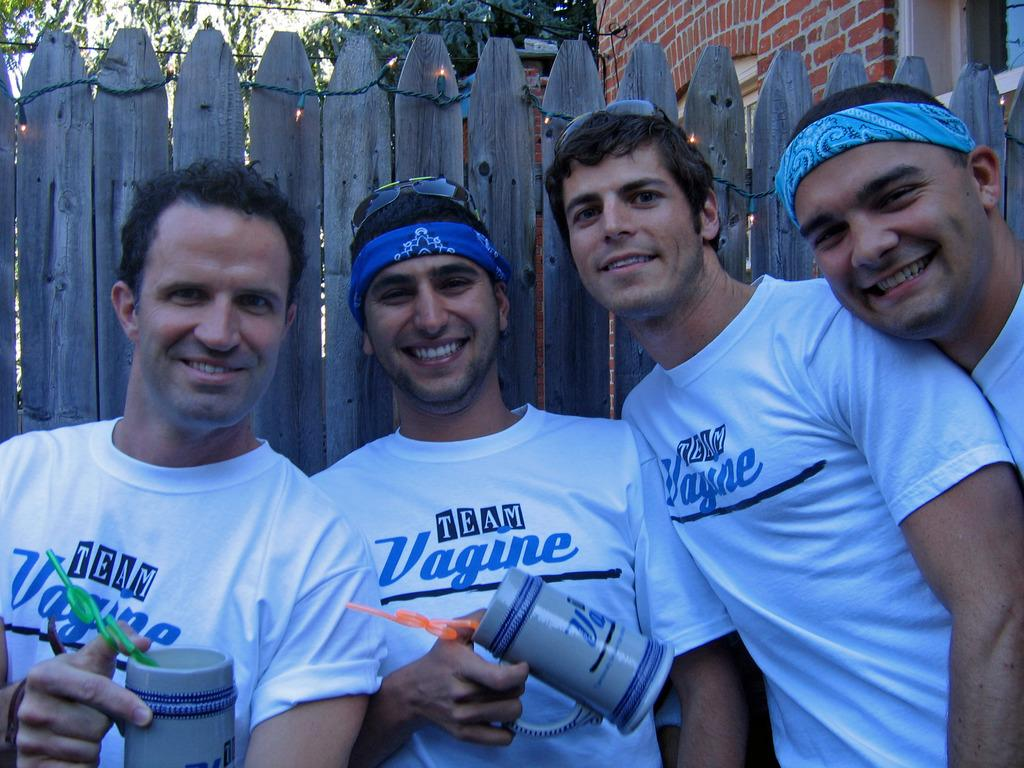<image>
Create a compact narrative representing the image presented. A group of men wearing white t-shirts depicting Team Vagine smile for the camera. 